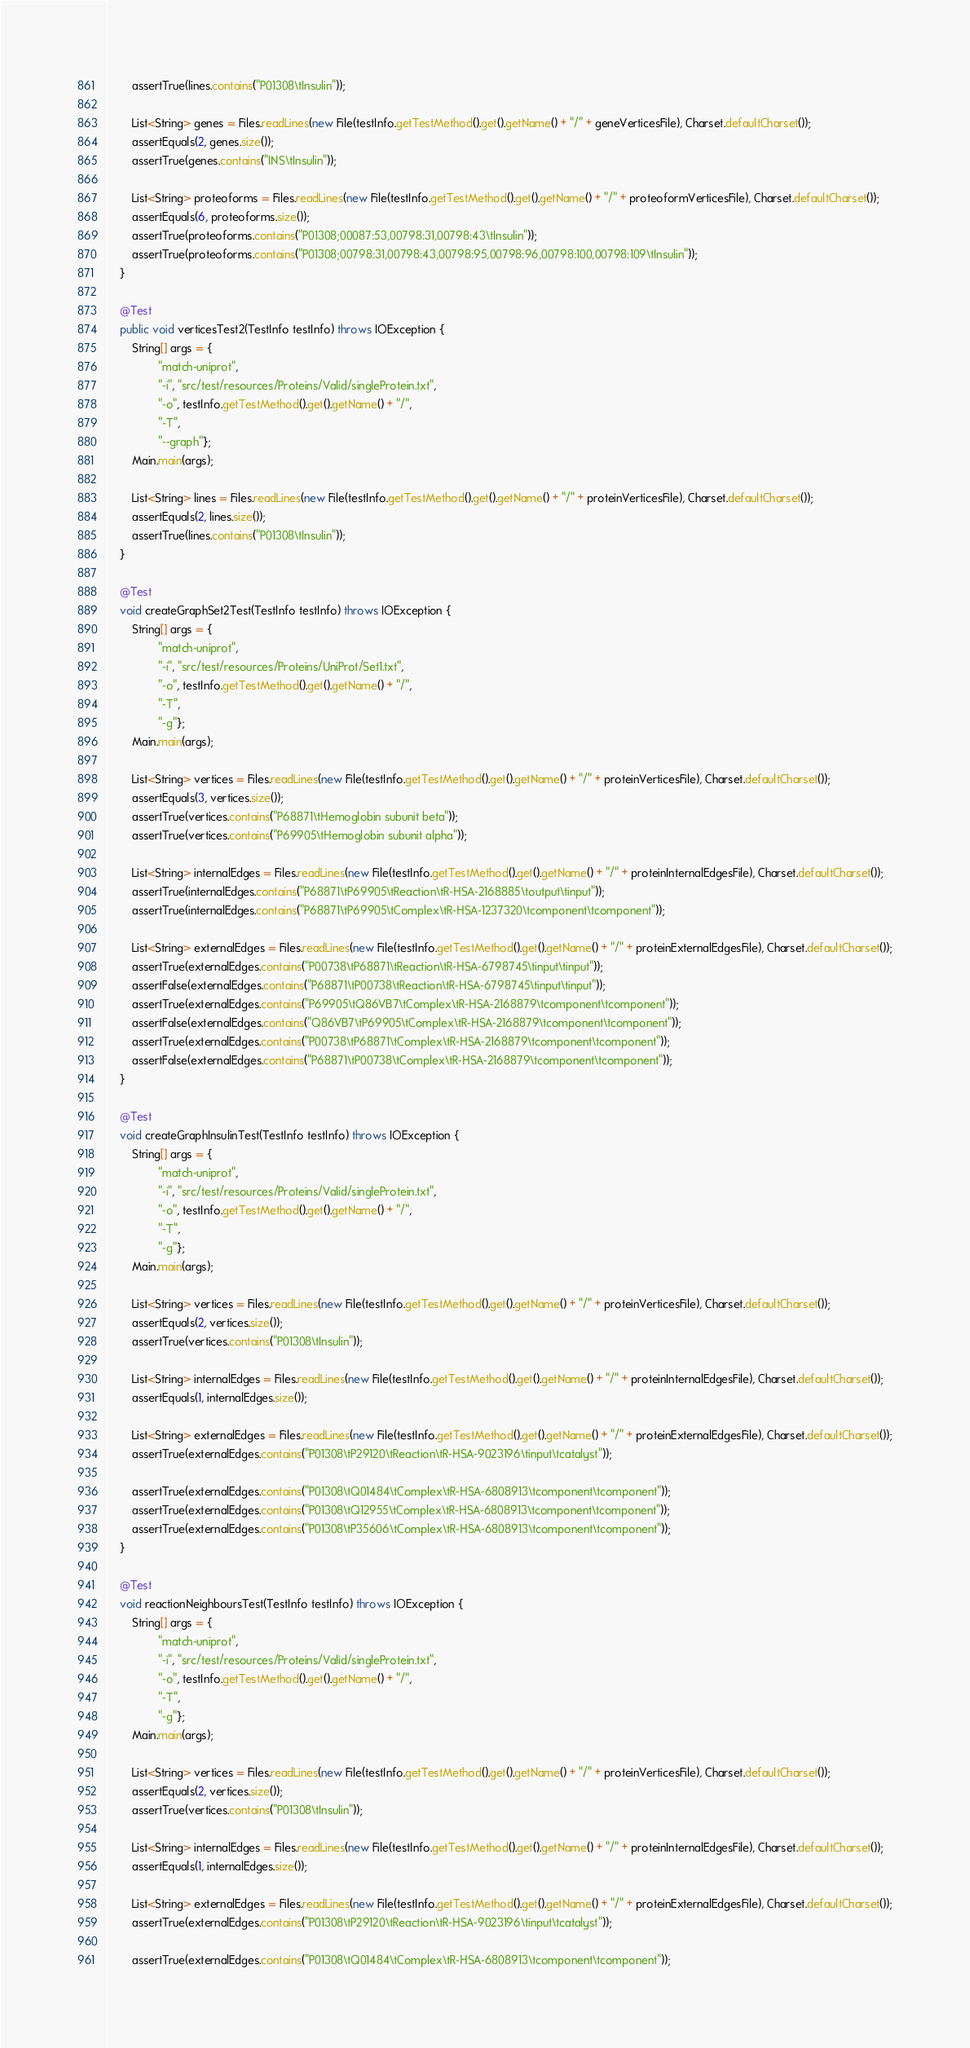Convert code to text. <code><loc_0><loc_0><loc_500><loc_500><_Java_>        assertTrue(lines.contains("P01308\tInsulin"));

        List<String> genes = Files.readLines(new File(testInfo.getTestMethod().get().getName() + "/" + geneVerticesFile), Charset.defaultCharset());
        assertEquals(2, genes.size());
        assertTrue(genes.contains("INS\tInsulin"));

        List<String> proteoforms = Files.readLines(new File(testInfo.getTestMethod().get().getName() + "/" + proteoformVerticesFile), Charset.defaultCharset());
        assertEquals(6, proteoforms.size());
        assertTrue(proteoforms.contains("P01308;00087:53,00798:31,00798:43\tInsulin"));
        assertTrue(proteoforms.contains("P01308;00798:31,00798:43,00798:95,00798:96,00798:100,00798:109\tInsulin"));
    }

    @Test
    public void verticesTest2(TestInfo testInfo) throws IOException {
        String[] args = {
                "match-uniprot",
                "-i", "src/test/resources/Proteins/Valid/singleProtein.txt",
                "-o", testInfo.getTestMethod().get().getName() + "/",
                "-T",
                "--graph"};
        Main.main(args);

        List<String> lines = Files.readLines(new File(testInfo.getTestMethod().get().getName() + "/" + proteinVerticesFile), Charset.defaultCharset());
        assertEquals(2, lines.size());
        assertTrue(lines.contains("P01308\tInsulin"));
    }

    @Test
    void createGraphSet2Test(TestInfo testInfo) throws IOException {
        String[] args = {
                "match-uniprot",
                "-i", "src/test/resources/Proteins/UniProt/Set1.txt",
                "-o", testInfo.getTestMethod().get().getName() + "/",
                "-T",
                "-g"};
        Main.main(args);

        List<String> vertices = Files.readLines(new File(testInfo.getTestMethod().get().getName() + "/" + proteinVerticesFile), Charset.defaultCharset());
        assertEquals(3, vertices.size());
        assertTrue(vertices.contains("P68871\tHemoglobin subunit beta"));
        assertTrue(vertices.contains("P69905\tHemoglobin subunit alpha"));

        List<String> internalEdges = Files.readLines(new File(testInfo.getTestMethod().get().getName() + "/" + proteinInternalEdgesFile), Charset.defaultCharset());
        assertTrue(internalEdges.contains("P68871\tP69905\tReaction\tR-HSA-2168885\toutput\tinput"));
        assertTrue(internalEdges.contains("P68871\tP69905\tComplex\tR-HSA-1237320\tcomponent\tcomponent"));

        List<String> externalEdges = Files.readLines(new File(testInfo.getTestMethod().get().getName() + "/" + proteinExternalEdgesFile), Charset.defaultCharset());
        assertTrue(externalEdges.contains("P00738\tP68871\tReaction\tR-HSA-6798745\tinput\tinput"));
        assertFalse(externalEdges.contains("P68871\tP00738\tReaction\tR-HSA-6798745\tinput\tinput"));
        assertTrue(externalEdges.contains("P69905\tQ86VB7\tComplex\tR-HSA-2168879\tcomponent\tcomponent"));
        assertFalse(externalEdges.contains("Q86VB7\tP69905\tComplex\tR-HSA-2168879\tcomponent\tcomponent"));
        assertTrue(externalEdges.contains("P00738\tP68871\tComplex\tR-HSA-2168879\tcomponent\tcomponent"));
        assertFalse(externalEdges.contains("P68871\tP00738\tComplex\tR-HSA-2168879\tcomponent\tcomponent"));
    }

    @Test
    void createGraphInsulinTest(TestInfo testInfo) throws IOException {
        String[] args = {
                "match-uniprot",
                "-i", "src/test/resources/Proteins/Valid/singleProtein.txt",
                "-o", testInfo.getTestMethod().get().getName() + "/",
                "-T",
                "-g"};
        Main.main(args);

        List<String> vertices = Files.readLines(new File(testInfo.getTestMethod().get().getName() + "/" + proteinVerticesFile), Charset.defaultCharset());
        assertEquals(2, vertices.size());
        assertTrue(vertices.contains("P01308\tInsulin"));

        List<String> internalEdges = Files.readLines(new File(testInfo.getTestMethod().get().getName() + "/" + proteinInternalEdgesFile), Charset.defaultCharset());
        assertEquals(1, internalEdges.size());

        List<String> externalEdges = Files.readLines(new File(testInfo.getTestMethod().get().getName() + "/" + proteinExternalEdgesFile), Charset.defaultCharset());
        assertTrue(externalEdges.contains("P01308\tP29120\tReaction\tR-HSA-9023196\tinput\tcatalyst"));

        assertTrue(externalEdges.contains("P01308\tQ01484\tComplex\tR-HSA-6808913\tcomponent\tcomponent"));
        assertTrue(externalEdges.contains("P01308\tQ12955\tComplex\tR-HSA-6808913\tcomponent\tcomponent"));
        assertTrue(externalEdges.contains("P01308\tP35606\tComplex\tR-HSA-6808913\tcomponent\tcomponent"));
    }

    @Test
    void reactionNeighboursTest(TestInfo testInfo) throws IOException {
        String[] args = {
                "match-uniprot",
                "-i", "src/test/resources/Proteins/Valid/singleProtein.txt",
                "-o", testInfo.getTestMethod().get().getName() + "/",
                "-T",
                "-g"};
        Main.main(args);

        List<String> vertices = Files.readLines(new File(testInfo.getTestMethod().get().getName() + "/" + proteinVerticesFile), Charset.defaultCharset());
        assertEquals(2, vertices.size());
        assertTrue(vertices.contains("P01308\tInsulin"));

        List<String> internalEdges = Files.readLines(new File(testInfo.getTestMethod().get().getName() + "/" + proteinInternalEdgesFile), Charset.defaultCharset());
        assertEquals(1, internalEdges.size());

        List<String> externalEdges = Files.readLines(new File(testInfo.getTestMethod().get().getName() + "/" + proteinExternalEdgesFile), Charset.defaultCharset());
        assertTrue(externalEdges.contains("P01308\tP29120\tReaction\tR-HSA-9023196\tinput\tcatalyst"));

        assertTrue(externalEdges.contains("P01308\tQ01484\tComplex\tR-HSA-6808913\tcomponent\tcomponent"));</code> 